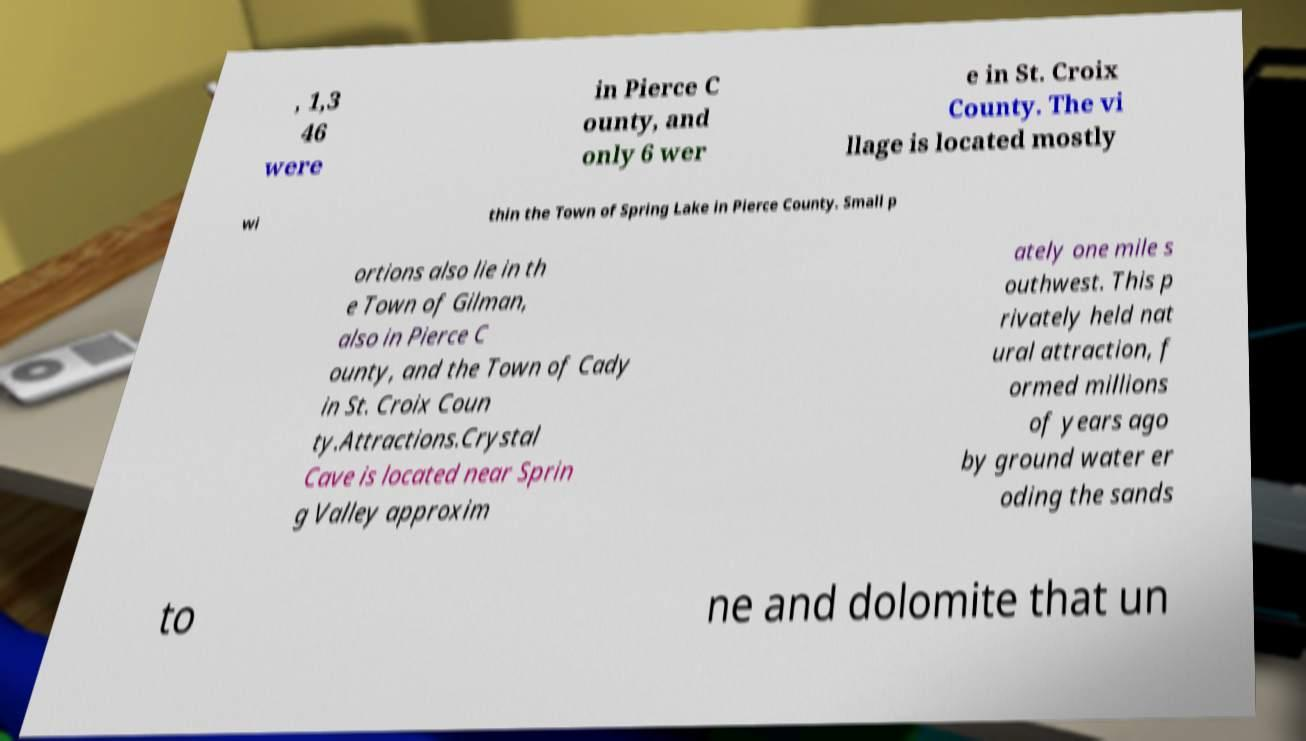What messages or text are displayed in this image? I need them in a readable, typed format. , 1,3 46 were in Pierce C ounty, and only 6 wer e in St. Croix County. The vi llage is located mostly wi thin the Town of Spring Lake in Pierce County. Small p ortions also lie in th e Town of Gilman, also in Pierce C ounty, and the Town of Cady in St. Croix Coun ty.Attractions.Crystal Cave is located near Sprin g Valley approxim ately one mile s outhwest. This p rivately held nat ural attraction, f ormed millions of years ago by ground water er oding the sands to ne and dolomite that un 